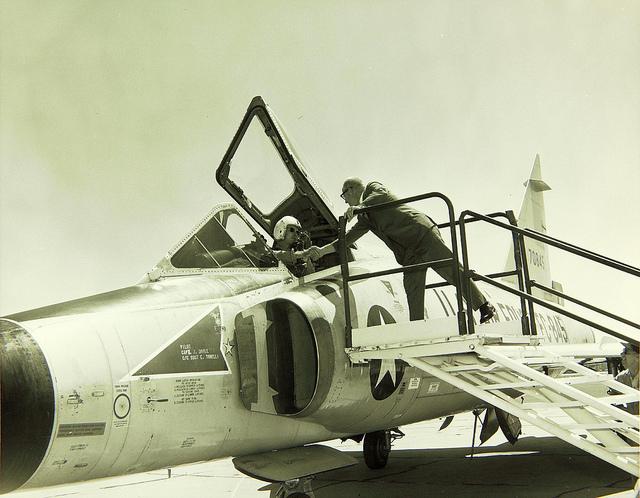How many stars are painted on the side of the plane?
Write a very short answer. 1. Is this a passenger plane?
Be succinct. No. How is the airplane powered?
Keep it brief. Fuel. 